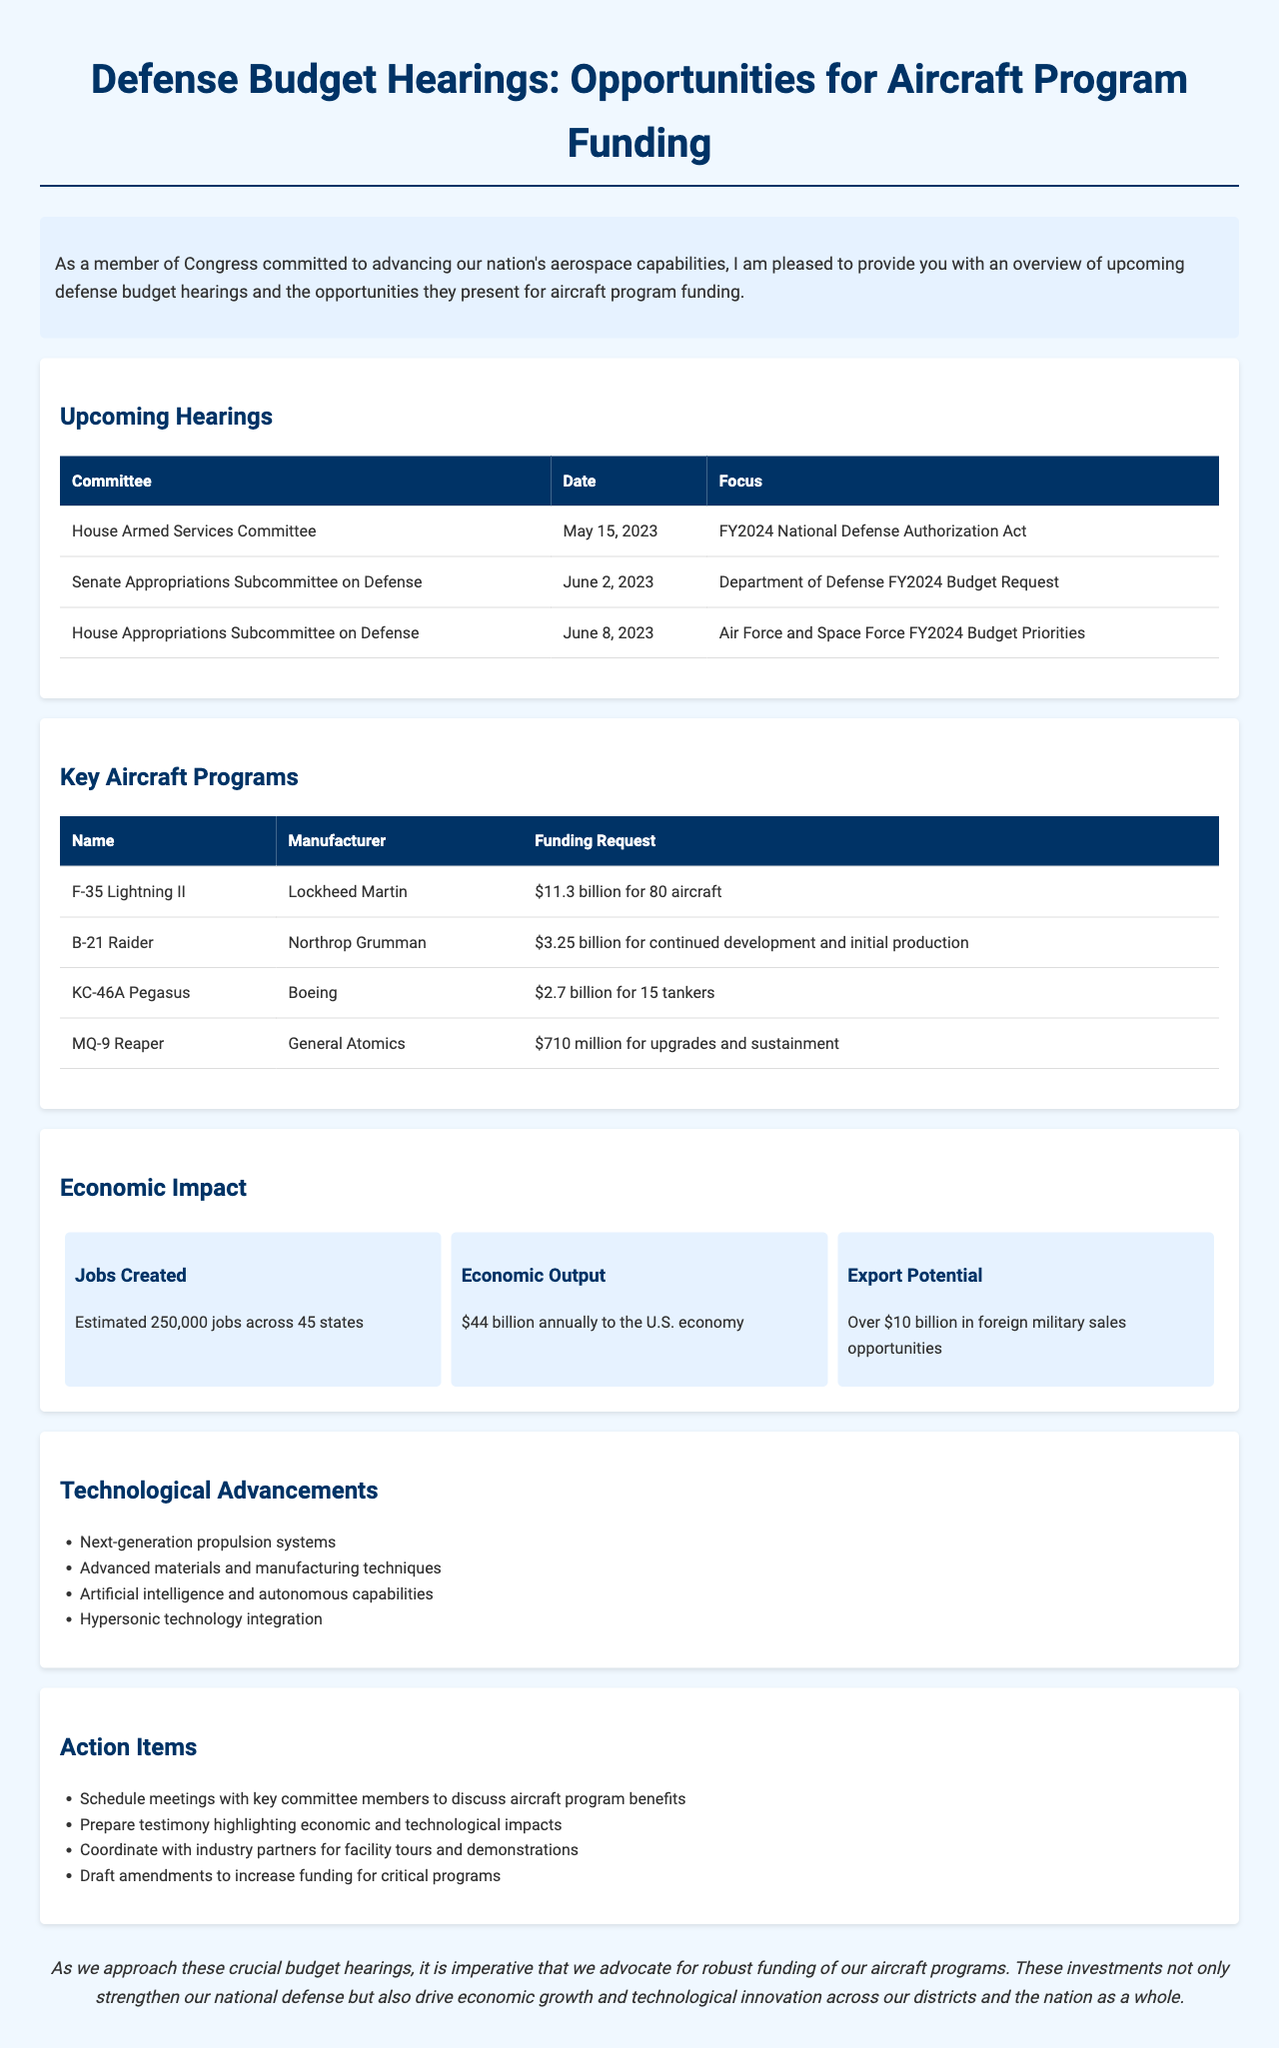What is the date of the House Armed Services Committee hearing? The date for the House Armed Services Committee hearing is listed in the upcoming hearings section of the document.
Answer: May 15, 2023 What is the funding request for the F-35 Lightning II program? The funding request for the F-35 Lightning II program includes the specific amount mentioned in the key aircraft programs section.
Answer: $11.3 billion for 80 aircraft Who is the manufacturer of the B-21 Raider? The manufacturer of the B-21 Raider is specified under the key aircraft programs section.
Answer: Northrop Grumman How many jobs are estimated to be created from the aircraft programs? The document states the estimated number of jobs created as part of the economic impact section.
Answer: 250,000 What are the four technological advancements mentioned in the newsletter? The document lists several technological advancements; by referring to this section, we see they are all highlighted under a specific section of technological advancements.
Answer: Next-generation propulsion systems, Advanced materials and manufacturing techniques, Artificial intelligence and autonomous capabilities, Hypersonic technology integration What action item involves meetings with key committee members? The document specifies action items regarding engaging with committee members to advocate for funding.
Answer: Schedule meetings with key committee members to discuss aircraft program benefits What is the primary focus of the June 8, 2023 hearing? The primary focus of the June 8 hearing can be found under the upcoming hearings section indicating what topic will be addressed.
Answer: Air Force and Space Force FY2024 Budget Priorities 